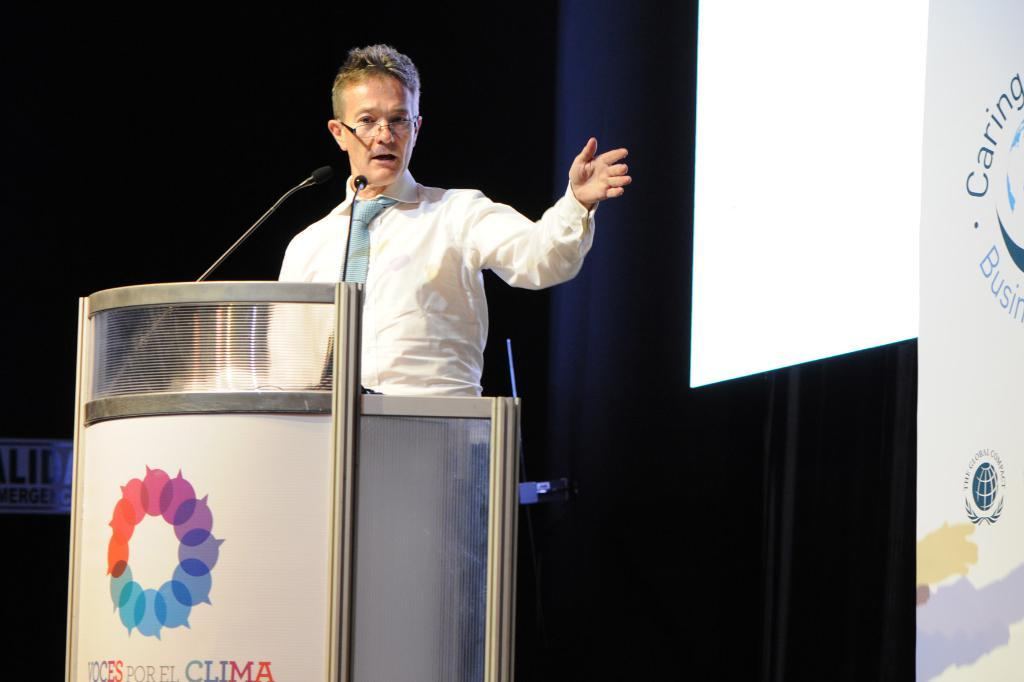<image>
Summarize the visual content of the image. A man giving a speech at a podium labeled Voces Por El Clima 